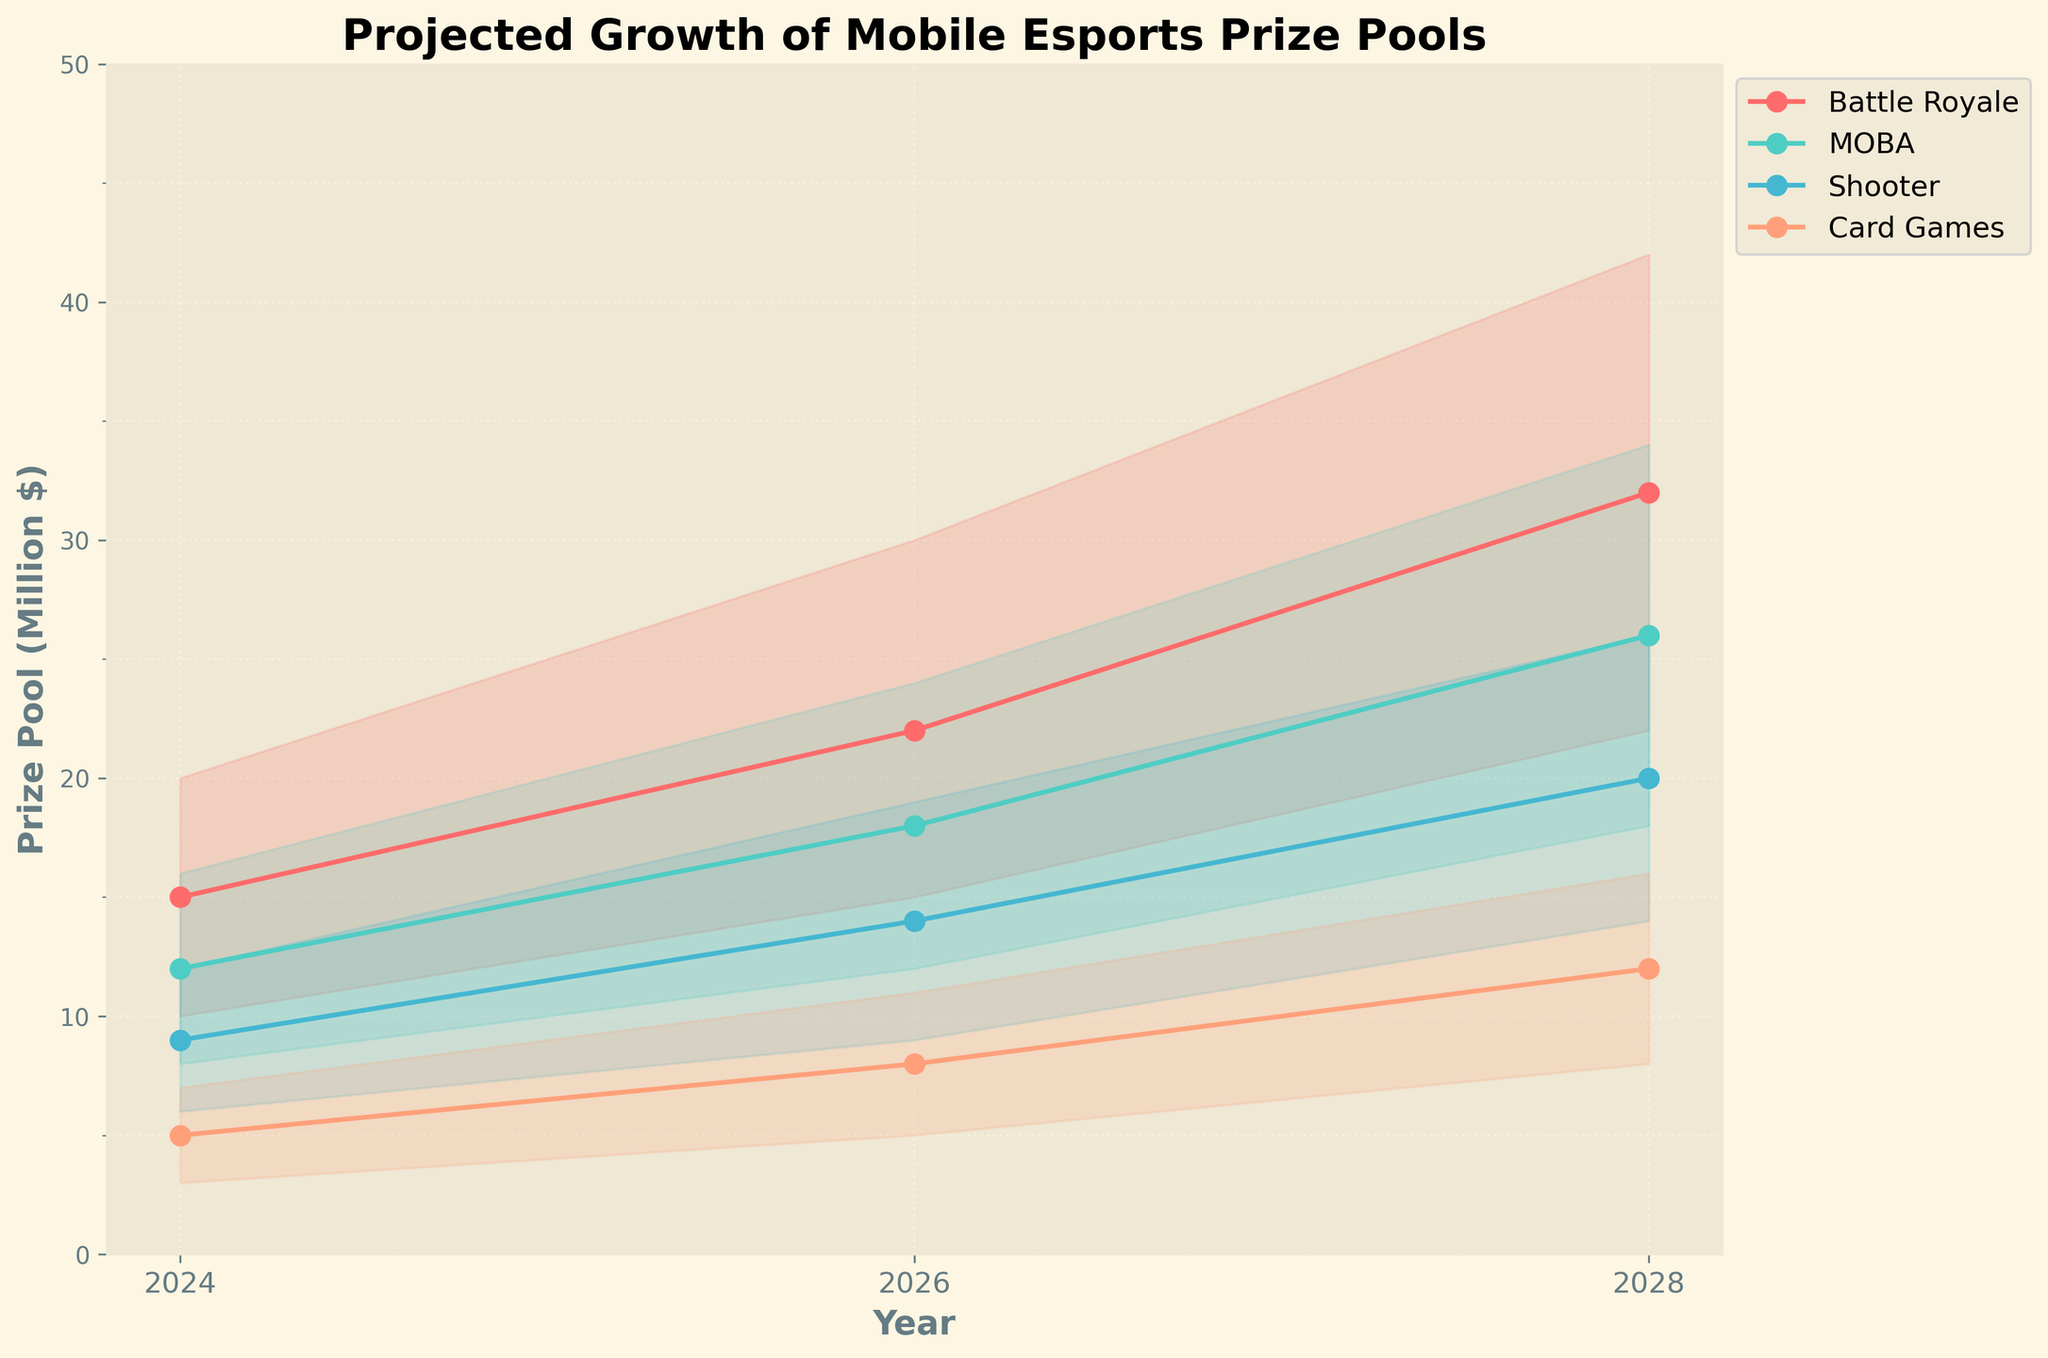What is the title of the chart? The title of the chart is located at the top and usually describes the main topic or purpose of the chart.
Answer: Projected Growth of Mobile Esports Prize Pools Which year shows the highest high estimate for Battle Royale? To find the highest high estimate, look at the Battle Royale category and compare the high estimates across the years: 2024 (20M), 2026 (30M), and 2028 (42M). The highest value is in 2028.
Answer: 2028 What is the medium estimate for MOBA in 2026? Find the medium estimate line for the MOBA category. For the year 2026, the medium estimate is shown directly on the y-axis.
Answer: 18 million dollars How many categories are displayed in the chart? The chart shows separate lines for each game category, which are color-coded and listed in the legend.
Answer: 4 Which game category has the smallest low estimate in 2024, and what is its value? Examine the low estimates for each category in 2024: Battle Royale (10M), MOBA (8M), Shooter (6M), and Card Games (3M). The smallest value is for Card Games.
Answer: Card Games, 3 million dollars What is the range of prize pool estimates for Shooter in 2026? The range is calculated by subtracting the low estimate from the high estimate for Shooter in 2026: 19M (high) - 9M (low) = 10M.
Answer: 10 million dollars Compare the medium estimate growth for Card Games from 2024 to 2028. By how much did it increase? Find the medium estimates for Card Games in 2024 (5M) and 2028 (12M). Subtract the 2024 value from the 2028 value: 12M - 5M = 7M.
Answer: 7 million dollars In which year does the MOBA prize pool have the least difference between its high and low estimates? Calculate the difference between high and low estimates in each year for MOBA: 2024 (8M), 2026 (12M), 2028 (16M). The smallest difference is in 2024.
Answer: 2024 What is the average of the high estimates for Battle Royale across all years? Add the high estimates for Battle Royale for each year: 20M (2024) + 30M (2026) + 42M (2028) = 92M. Divide the sum by the number of years (3): 92M / 3 ≈ 30.67M.
Answer: 30.67 million dollars 